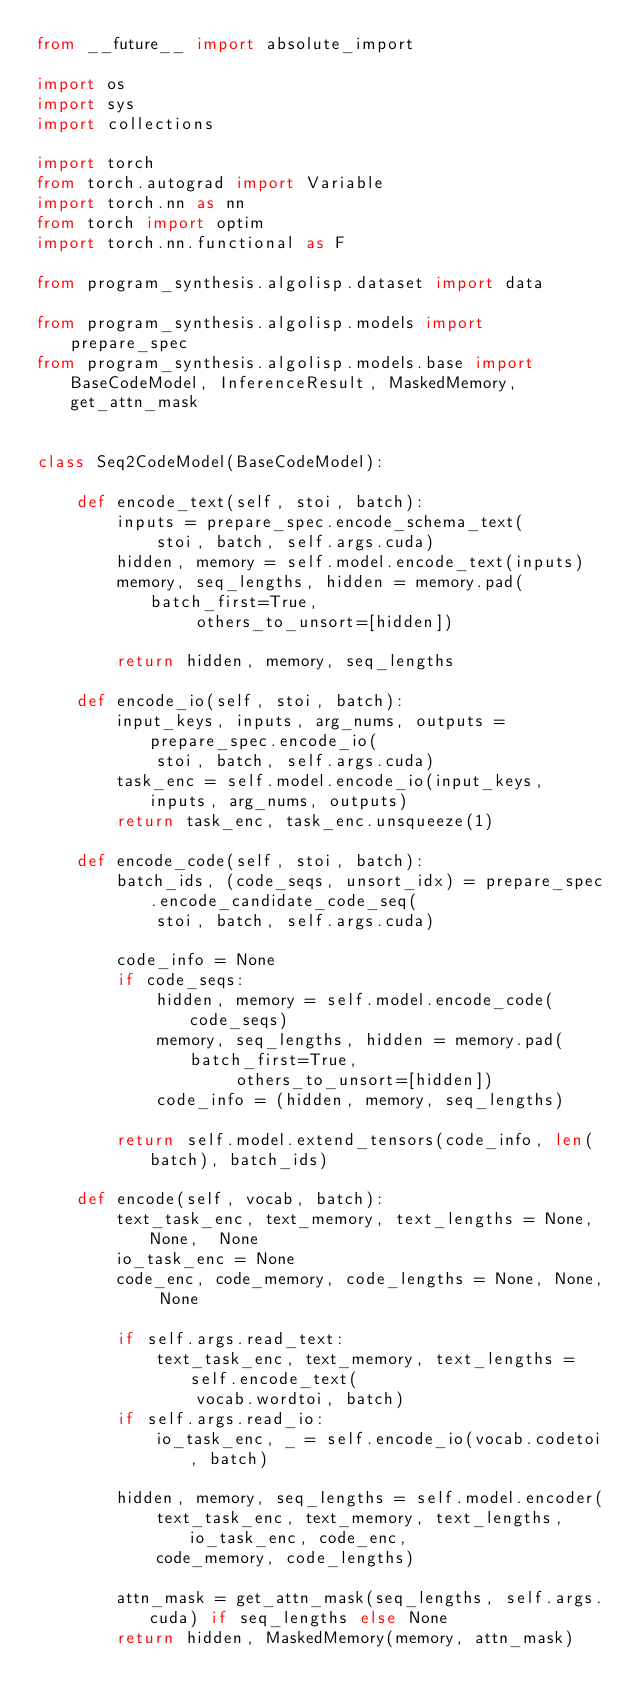<code> <loc_0><loc_0><loc_500><loc_500><_Python_>from __future__ import absolute_import

import os
import sys
import collections

import torch
from torch.autograd import Variable
import torch.nn as nn
from torch import optim
import torch.nn.functional as F

from program_synthesis.algolisp.dataset import data

from program_synthesis.algolisp.models import prepare_spec
from program_synthesis.algolisp.models.base import BaseCodeModel, InferenceResult, MaskedMemory, get_attn_mask


class Seq2CodeModel(BaseCodeModel):

    def encode_text(self, stoi, batch):
        inputs = prepare_spec.encode_schema_text(
            stoi, batch, self.args.cuda)
        hidden, memory = self.model.encode_text(inputs)
        memory, seq_lengths, hidden = memory.pad(batch_first=True,
                others_to_unsort=[hidden])

        return hidden, memory, seq_lengths

    def encode_io(self, stoi, batch):
        input_keys, inputs, arg_nums, outputs = prepare_spec.encode_io(
            stoi, batch, self.args.cuda)
        task_enc = self.model.encode_io(input_keys, inputs, arg_nums, outputs)
        return task_enc, task_enc.unsqueeze(1)

    def encode_code(self, stoi, batch):
        batch_ids, (code_seqs, unsort_idx) = prepare_spec.encode_candidate_code_seq(
            stoi, batch, self.args.cuda)

        code_info = None
        if code_seqs:
            hidden, memory = self.model.encode_code(code_seqs)
            memory, seq_lengths, hidden = memory.pad(batch_first=True,
                    others_to_unsort=[hidden])
            code_info = (hidden, memory, seq_lengths)

        return self.model.extend_tensors(code_info, len(batch), batch_ids)

    def encode(self, vocab, batch):
        text_task_enc, text_memory, text_lengths = None, None,  None
        io_task_enc = None
        code_enc, code_memory, code_lengths = None, None, None

        if self.args.read_text:
            text_task_enc, text_memory, text_lengths = self.encode_text(
                vocab.wordtoi, batch)
        if self.args.read_io:
            io_task_enc, _ = self.encode_io(vocab.codetoi, batch)

        hidden, memory, seq_lengths = self.model.encoder(
            text_task_enc, text_memory, text_lengths, io_task_enc, code_enc,
            code_memory, code_lengths)

        attn_mask = get_attn_mask(seq_lengths, self.args.cuda) if seq_lengths else None
        return hidden, MaskedMemory(memory, attn_mask)
</code> 